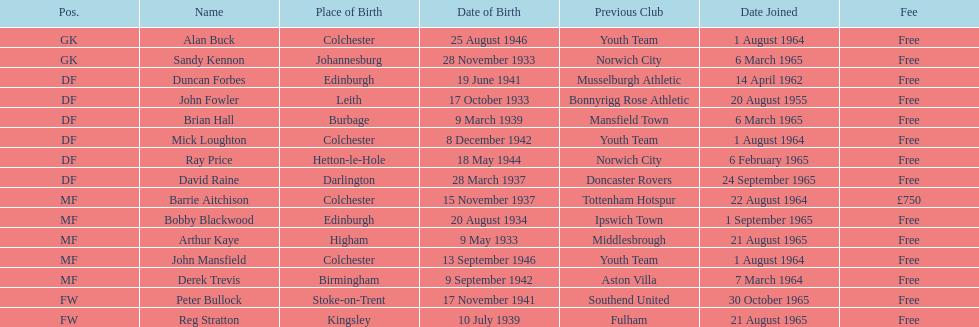What is the alternate cost specified, aside from free? £750. 